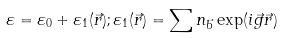Convert formula to latex. <formula><loc_0><loc_0><loc_500><loc_500>\varepsilon = \varepsilon _ { 0 } + \varepsilon _ { 1 } ( \vec { r } ) ; \varepsilon _ { 1 } ( \vec { r } ) = \sum n _ { \vec { b } } \exp ( i \vec { g } \vec { r } )</formula> 